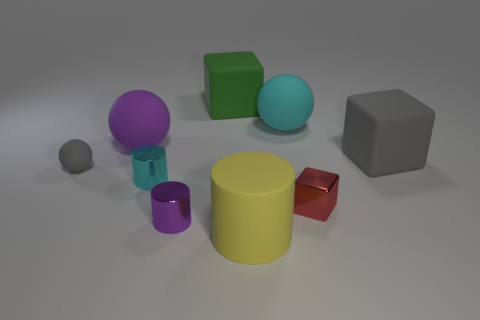What is the size of the matte cube that is the same color as the small rubber object?
Provide a succinct answer. Large. What size is the yellow thing that is the same material as the large cyan ball?
Give a very brief answer. Large. Are there any yellow rubber cylinders behind the small cyan metal thing?
Your answer should be compact. No. What is the size of the other metallic thing that is the same shape as the cyan shiny object?
Keep it short and to the point. Small. Is the color of the small ball the same as the ball right of the cyan shiny thing?
Keep it short and to the point. No. Do the small metal cube and the matte cylinder have the same color?
Your answer should be very brief. No. Is the number of green rubber balls less than the number of balls?
Give a very brief answer. Yes. How many other things are there of the same color as the small block?
Offer a terse response. 0. How many big cyan cylinders are there?
Offer a terse response. 0. Is the number of big rubber objects that are in front of the yellow cylinder less than the number of yellow things?
Offer a terse response. Yes. 